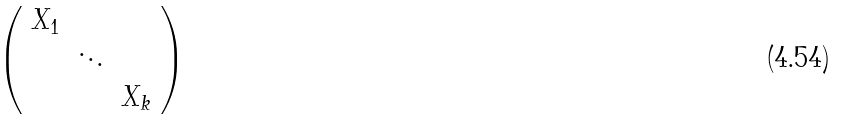<formula> <loc_0><loc_0><loc_500><loc_500>\left ( \begin{array} { c c c c } X _ { 1 } & & \\ & \ddots & \\ & & X _ { k } \end{array} \right )</formula> 